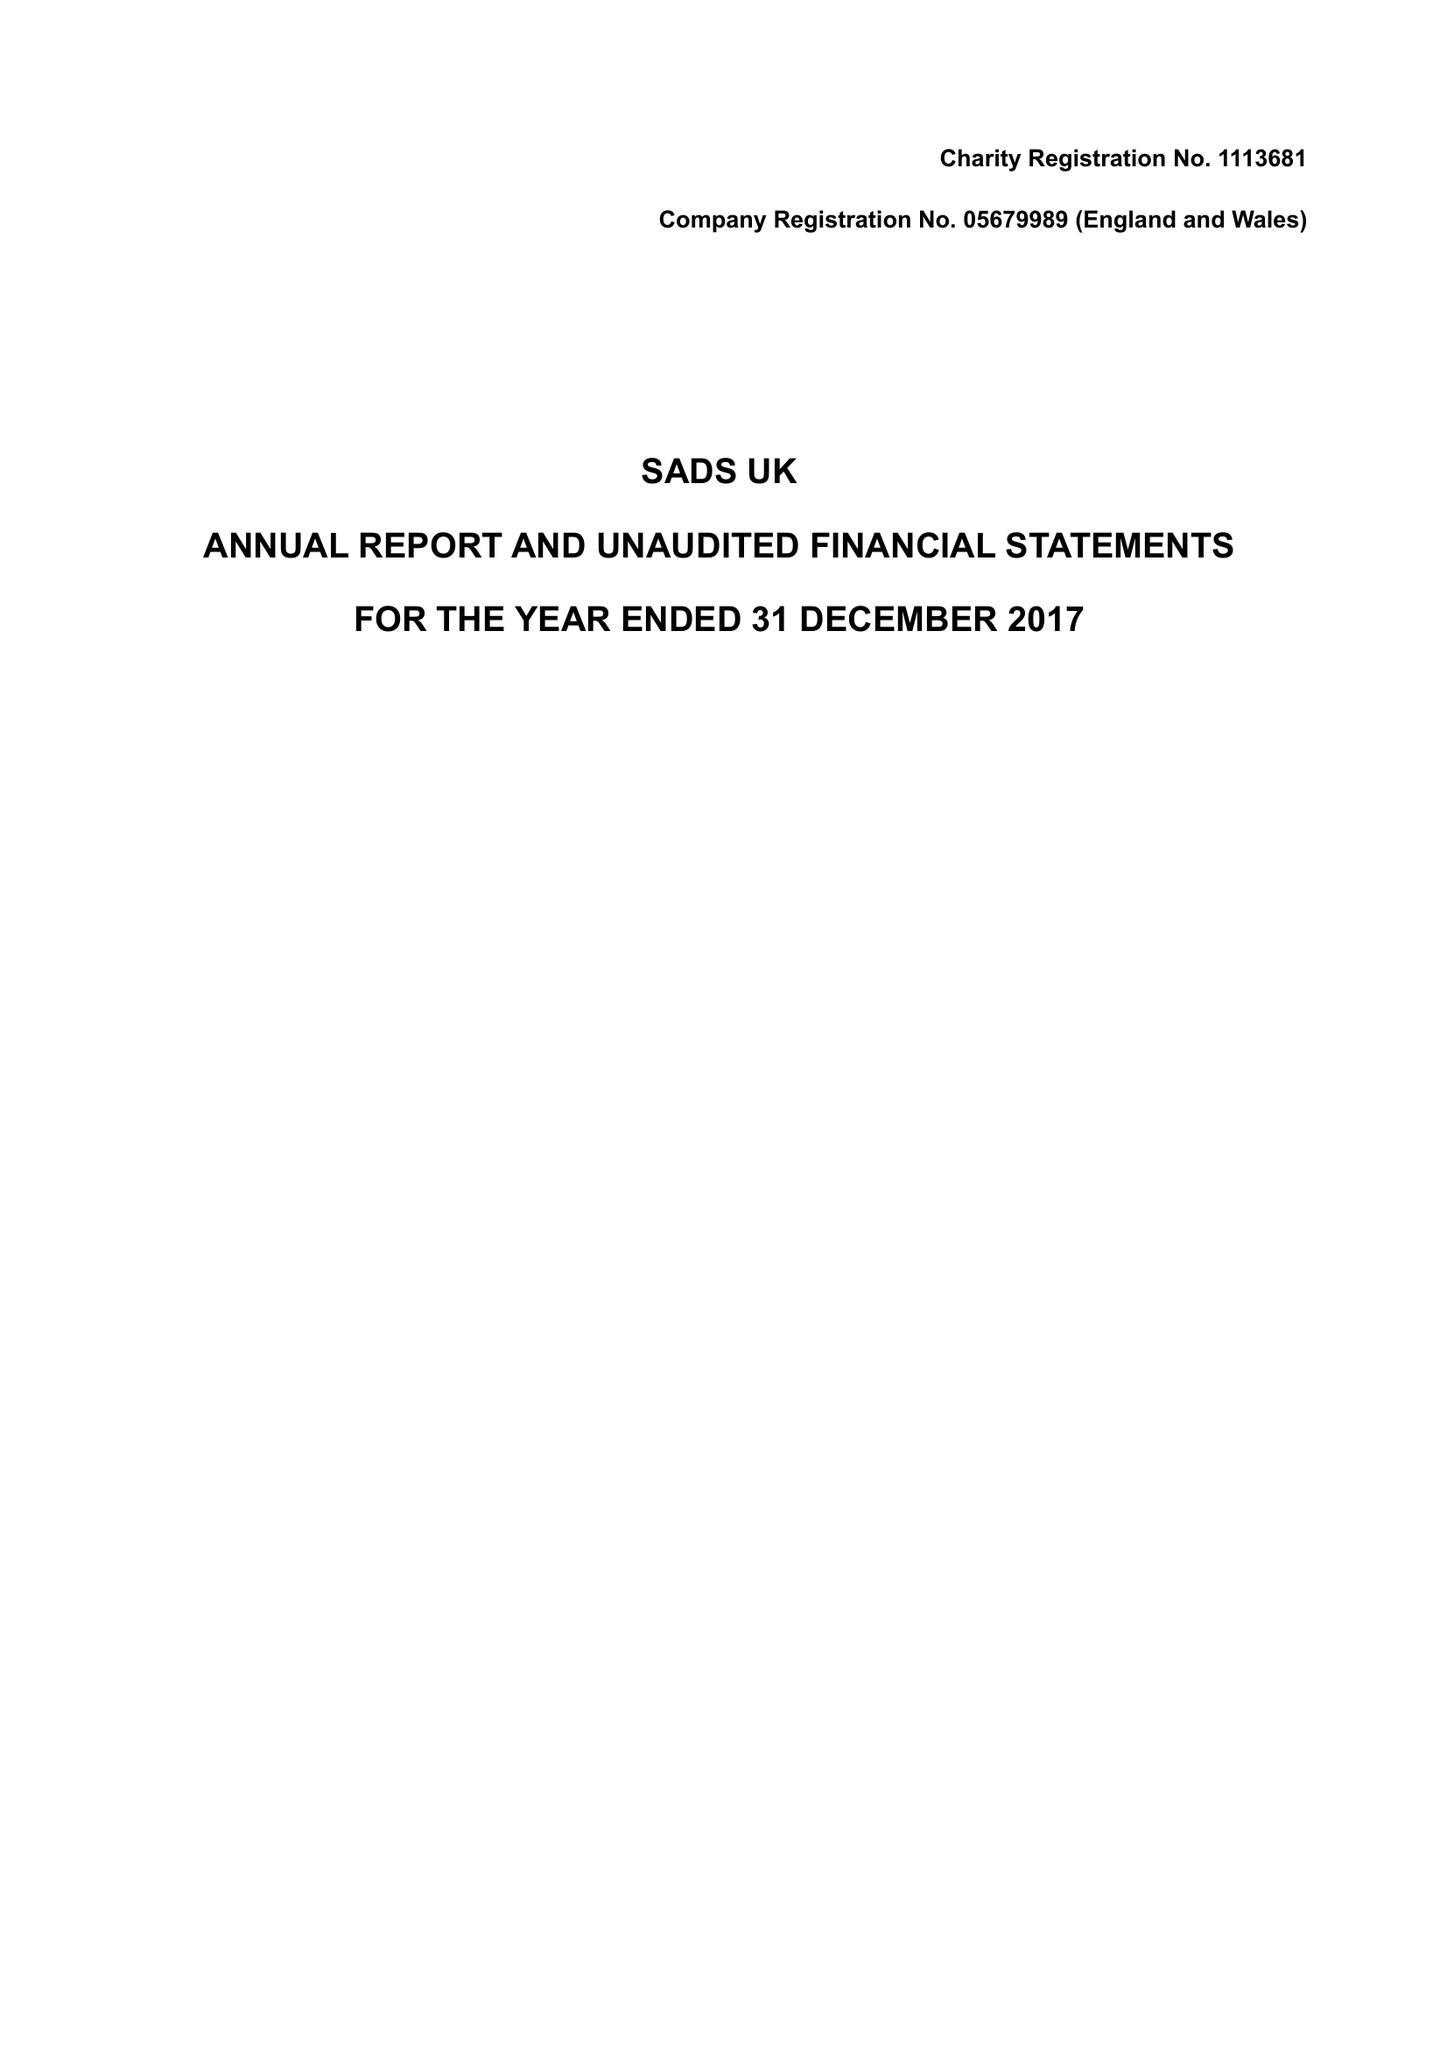What is the value for the address__street_line?
Answer the question using a single word or phrase. 22 ROWHEDGE 